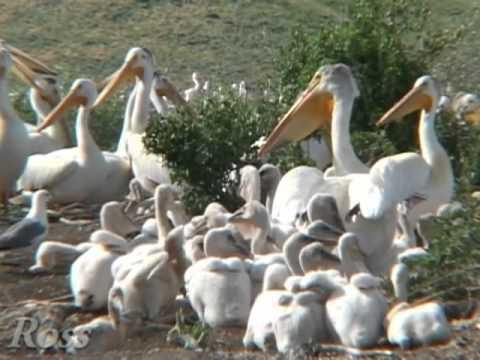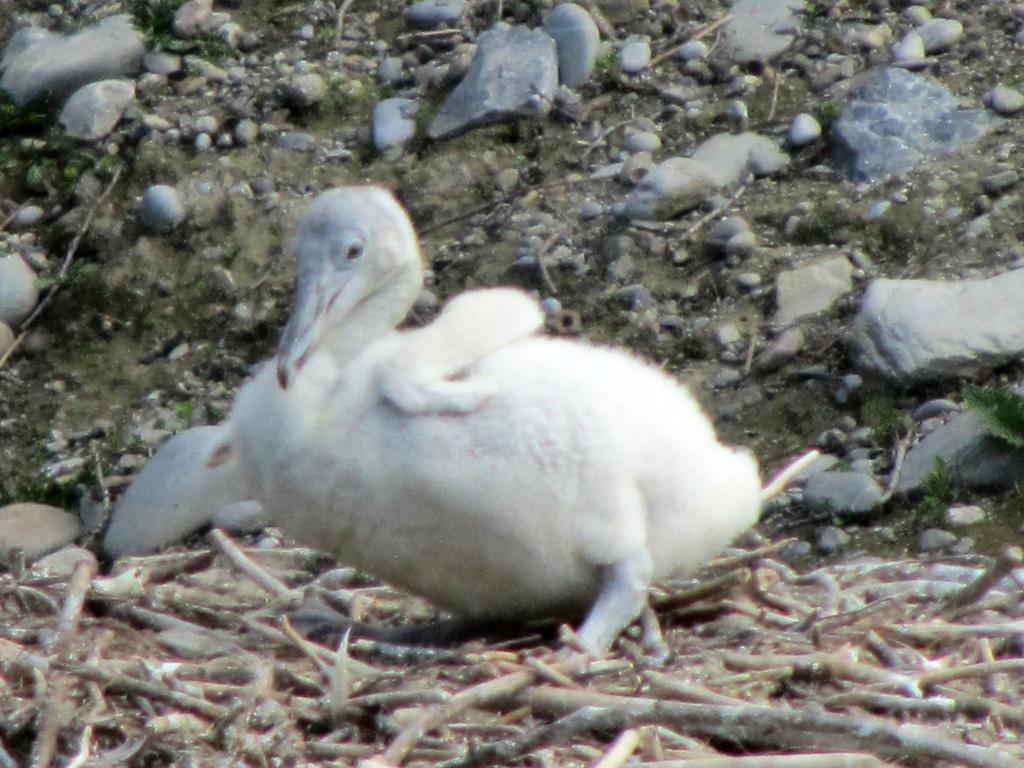The first image is the image on the left, the second image is the image on the right. Given the left and right images, does the statement "The bird in the image on the right is in a wet area." hold true? Answer yes or no. No. The first image is the image on the left, the second image is the image on the right. Given the left and right images, does the statement "An image shows a nest that includes a pelican with an open mouth in it." hold true? Answer yes or no. No. 